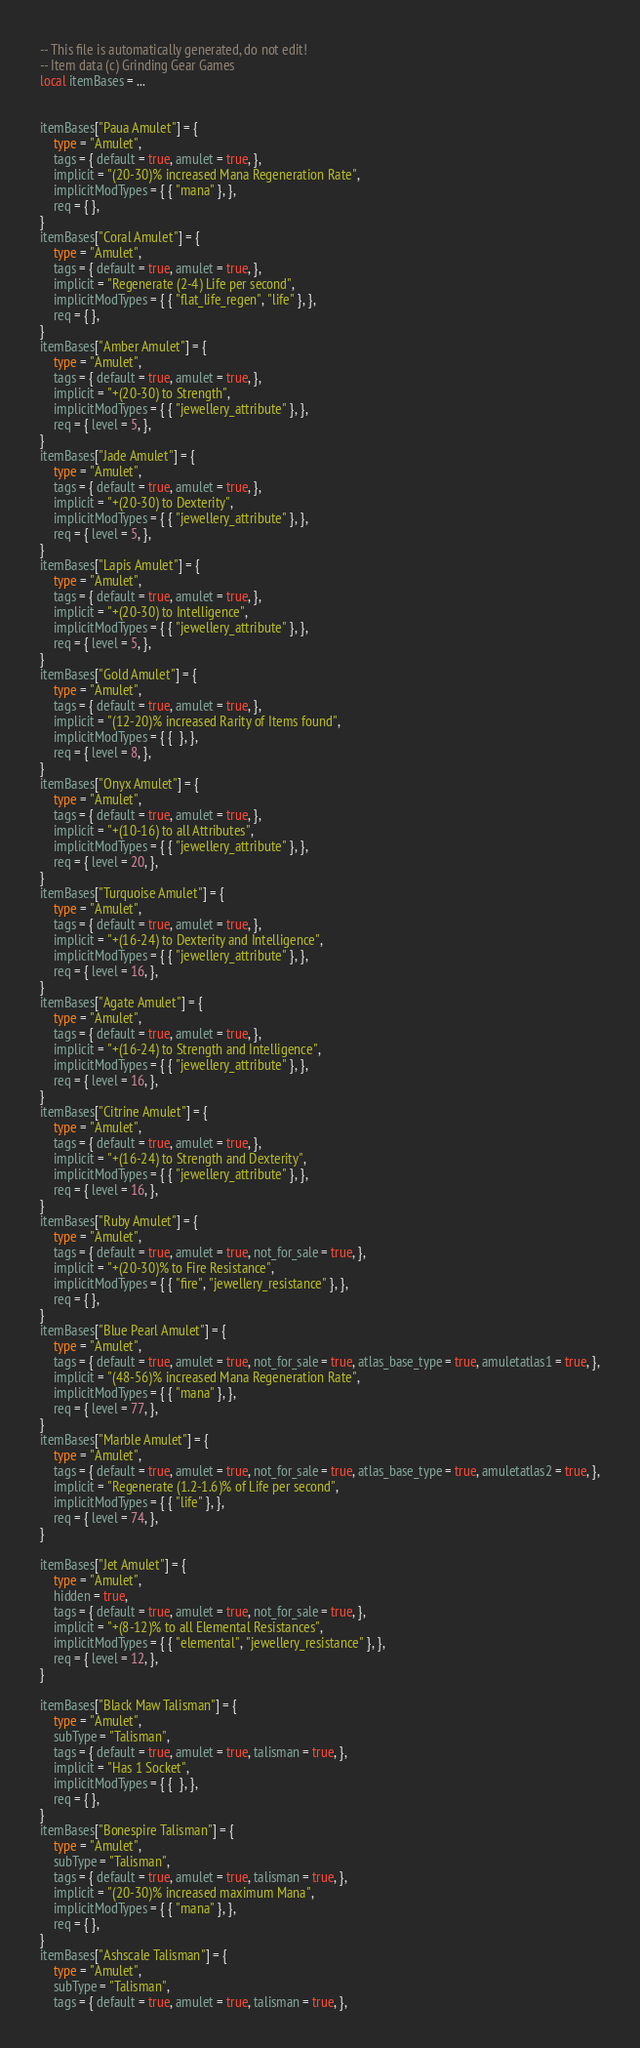Convert code to text. <code><loc_0><loc_0><loc_500><loc_500><_Lua_>-- This file is automatically generated, do not edit!
-- Item data (c) Grinding Gear Games
local itemBases = ...


itemBases["Paua Amulet"] = {
	type = "Amulet",
	tags = { default = true, amulet = true, },
	implicit = "(20-30)% increased Mana Regeneration Rate",
	implicitModTypes = { { "mana" }, },
	req = { },
}
itemBases["Coral Amulet"] = {
	type = "Amulet",
	tags = { default = true, amulet = true, },
	implicit = "Regenerate (2-4) Life per second",
	implicitModTypes = { { "flat_life_regen", "life" }, },
	req = { },
}
itemBases["Amber Amulet"] = {
	type = "Amulet",
	tags = { default = true, amulet = true, },
	implicit = "+(20-30) to Strength",
	implicitModTypes = { { "jewellery_attribute" }, },
	req = { level = 5, },
}
itemBases["Jade Amulet"] = {
	type = "Amulet",
	tags = { default = true, amulet = true, },
	implicit = "+(20-30) to Dexterity",
	implicitModTypes = { { "jewellery_attribute" }, },
	req = { level = 5, },
}
itemBases["Lapis Amulet"] = {
	type = "Amulet",
	tags = { default = true, amulet = true, },
	implicit = "+(20-30) to Intelligence",
	implicitModTypes = { { "jewellery_attribute" }, },
	req = { level = 5, },
}
itemBases["Gold Amulet"] = {
	type = "Amulet",
	tags = { default = true, amulet = true, },
	implicit = "(12-20)% increased Rarity of Items found",
	implicitModTypes = { {  }, },
	req = { level = 8, },
}
itemBases["Onyx Amulet"] = {
	type = "Amulet",
	tags = { default = true, amulet = true, },
	implicit = "+(10-16) to all Attributes",
	implicitModTypes = { { "jewellery_attribute" }, },
	req = { level = 20, },
}
itemBases["Turquoise Amulet"] = {
	type = "Amulet",
	tags = { default = true, amulet = true, },
	implicit = "+(16-24) to Dexterity and Intelligence",
	implicitModTypes = { { "jewellery_attribute" }, },
	req = { level = 16, },
}
itemBases["Agate Amulet"] = {
	type = "Amulet",
	tags = { default = true, amulet = true, },
	implicit = "+(16-24) to Strength and Intelligence",
	implicitModTypes = { { "jewellery_attribute" }, },
	req = { level = 16, },
}
itemBases["Citrine Amulet"] = {
	type = "Amulet",
	tags = { default = true, amulet = true, },
	implicit = "+(16-24) to Strength and Dexterity",
	implicitModTypes = { { "jewellery_attribute" }, },
	req = { level = 16, },
}
itemBases["Ruby Amulet"] = {
	type = "Amulet",
	tags = { default = true, amulet = true, not_for_sale = true, },
	implicit = "+(20-30)% to Fire Resistance",
	implicitModTypes = { { "fire", "jewellery_resistance" }, },
	req = { },
}
itemBases["Blue Pearl Amulet"] = {
	type = "Amulet",
	tags = { default = true, amulet = true, not_for_sale = true, atlas_base_type = true, amuletatlas1 = true, },
	implicit = "(48-56)% increased Mana Regeneration Rate",
	implicitModTypes = { { "mana" }, },
	req = { level = 77, },
}
itemBases["Marble Amulet"] = {
	type = "Amulet",
	tags = { default = true, amulet = true, not_for_sale = true, atlas_base_type = true, amuletatlas2 = true, },
	implicit = "Regenerate (1.2-1.6)% of Life per second",
	implicitModTypes = { { "life" }, },
	req = { level = 74, },
}

itemBases["Jet Amulet"] = {
	type = "Amulet",
	hidden = true,
	tags = { default = true, amulet = true, not_for_sale = true, },
	implicit = "+(8-12)% to all Elemental Resistances",
	implicitModTypes = { { "elemental", "jewellery_resistance" }, },
	req = { level = 12, },
}

itemBases["Black Maw Talisman"] = {
	type = "Amulet",
	subType = "Talisman",
	tags = { default = true, amulet = true, talisman = true, },
	implicit = "Has 1 Socket",
	implicitModTypes = { {  }, },
	req = { },
}
itemBases["Bonespire Talisman"] = {
	type = "Amulet",
	subType = "Talisman",
	tags = { default = true, amulet = true, talisman = true, },
	implicit = "(20-30)% increased maximum Mana",
	implicitModTypes = { { "mana" }, },
	req = { },
}
itemBases["Ashscale Talisman"] = {
	type = "Amulet",
	subType = "Talisman",
	tags = { default = true, amulet = true, talisman = true, },</code> 